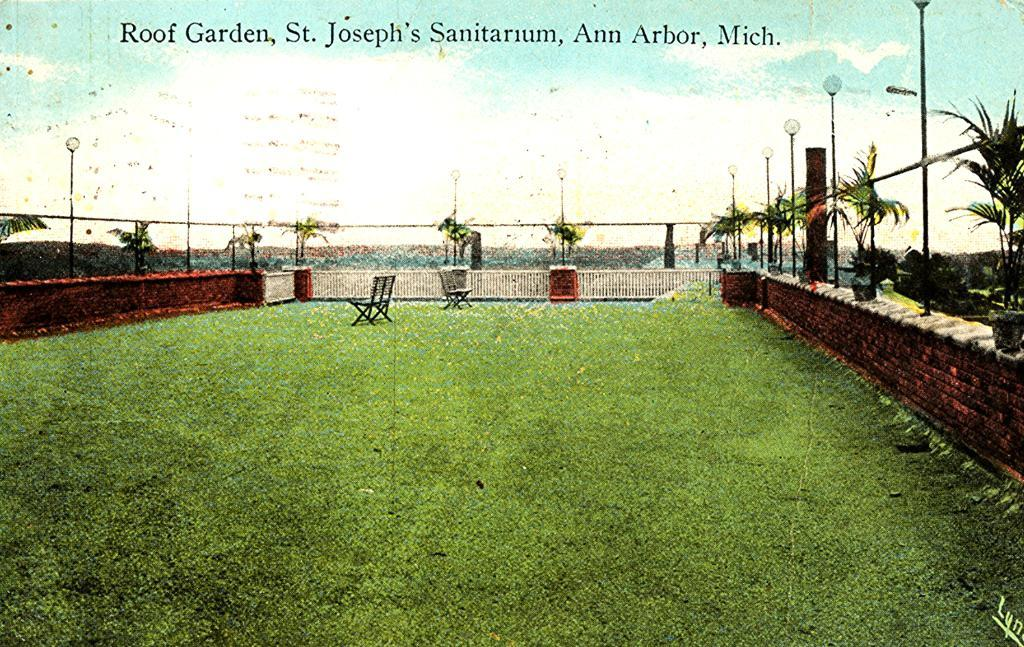What type of outdoor space is shown in the image? There is a lawn in the image. What furniture is present on the lawn? There are chairs in the image. Are there any decorative elements visible in the image? Yes, there are flower pots on the fencing. What can be seen in the background of the image? The sky is visible in the background of the image, and it is clear. How many cushions are placed on the chairs in the image? There is no mention of cushions on the chairs in the image. --- Facts: 1. There is a person holding a book in the image. 2. The person is sitting on a bench. 3. There is a tree in the background of the image. 4. The person is wearing a hat. Absurd Topics: bicycle, parrot, painting Conversation: What is the person in the image doing? The person is holding a book in the image. Where is the person sitting? The person is sitting on a bench. What can be seen in the background of the image? There is a tree in the background of the image. What type of headwear is the person wearing? The person is wearing a hat. Reasoning: Let's think step by step in order to produce the conversation. We start by identifying the main subject in the image, which is the person holding a book. Then, we describe the person's location, which is sitting on a bench. Next, we mention the background of the image, which is a tree. Finally, we describe the person's attire, which is a hat. Absurd Question/Answer: Can you tell me how many parrots are sitting on the person's shoulder in the image? There are no parrots present in the image. --- Facts: 1. There is a car in the image. 2. The car is parked on the street. 3. There are streetlights in the image. 4. The car has a red color. Absurd Topics: balloon, piano, ocean Conversation: What type of vehicle is in the image? There is a car in the image. Where is the car located? The car is parked on the street. What type of lighting is present in the image? There are streetlights in the image. What color is the car? The car has a red color. Reasoning: Let's think step by step in order to produce the conversation. We start by identifying the main subject in the image, which is the car. Then, we describe the car's location, which is parked on the street. Next, we mention the lighting present in the image, which are streetlights. Finally, we describe the car's color, which is red. Absurd Question/Answer: 